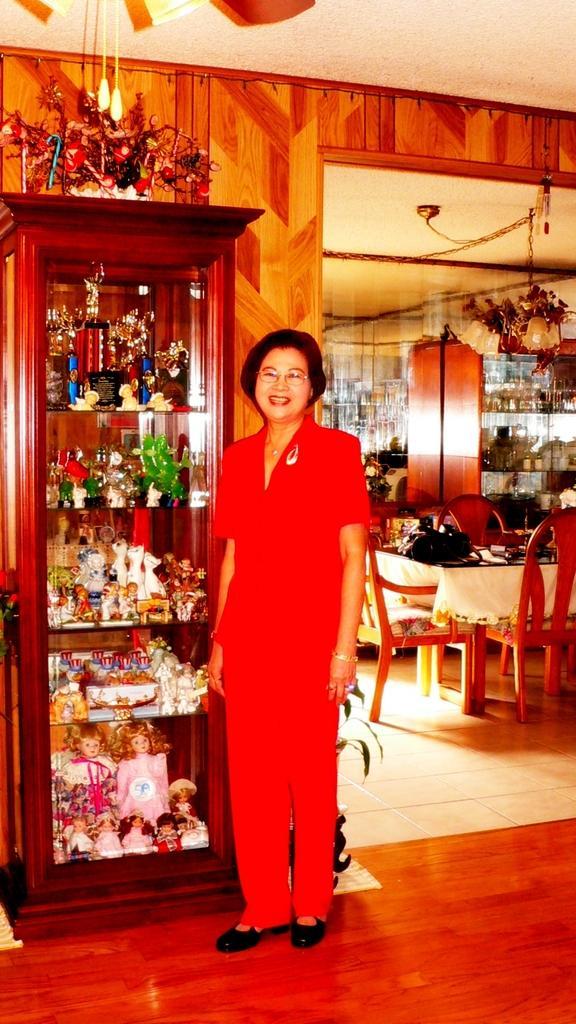Please provide a concise description of this image. On the background we can see cupboard, ceiling and a ceiling light. We can see empty chairs and tables. This is a floor. Here we can see one women in red dress standing near to the cupboard and smiling. Inside the cupboard we can see dolls. 